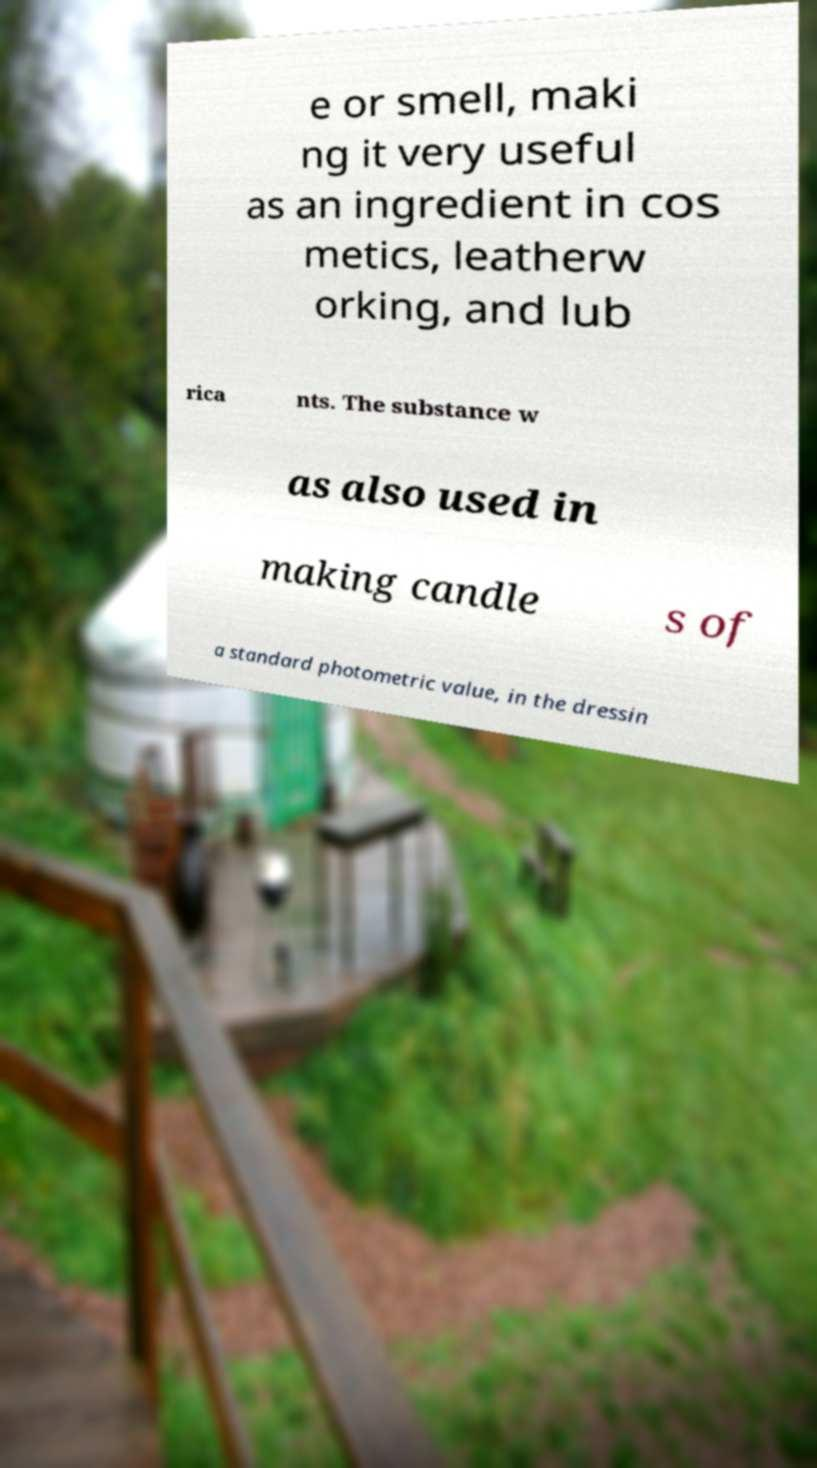Could you assist in decoding the text presented in this image and type it out clearly? e or smell, maki ng it very useful as an ingredient in cos metics, leatherw orking, and lub rica nts. The substance w as also used in making candle s of a standard photometric value, in the dressin 